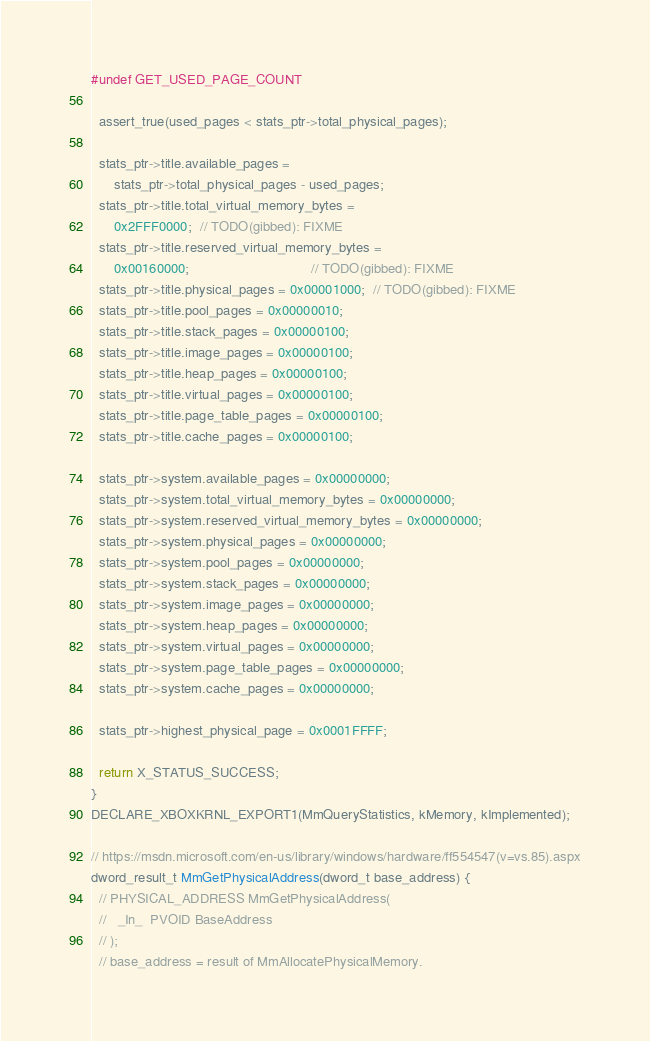Convert code to text. <code><loc_0><loc_0><loc_500><loc_500><_C++_>#undef GET_USED_PAGE_COUNT

  assert_true(used_pages < stats_ptr->total_physical_pages);

  stats_ptr->title.available_pages =
      stats_ptr->total_physical_pages - used_pages;
  stats_ptr->title.total_virtual_memory_bytes =
      0x2FFF0000;  // TODO(gibbed): FIXME
  stats_ptr->title.reserved_virtual_memory_bytes =
      0x00160000;                                // TODO(gibbed): FIXME
  stats_ptr->title.physical_pages = 0x00001000;  // TODO(gibbed): FIXME
  stats_ptr->title.pool_pages = 0x00000010;
  stats_ptr->title.stack_pages = 0x00000100;
  stats_ptr->title.image_pages = 0x00000100;
  stats_ptr->title.heap_pages = 0x00000100;
  stats_ptr->title.virtual_pages = 0x00000100;
  stats_ptr->title.page_table_pages = 0x00000100;
  stats_ptr->title.cache_pages = 0x00000100;

  stats_ptr->system.available_pages = 0x00000000;
  stats_ptr->system.total_virtual_memory_bytes = 0x00000000;
  stats_ptr->system.reserved_virtual_memory_bytes = 0x00000000;
  stats_ptr->system.physical_pages = 0x00000000;
  stats_ptr->system.pool_pages = 0x00000000;
  stats_ptr->system.stack_pages = 0x00000000;
  stats_ptr->system.image_pages = 0x00000000;
  stats_ptr->system.heap_pages = 0x00000000;
  stats_ptr->system.virtual_pages = 0x00000000;
  stats_ptr->system.page_table_pages = 0x00000000;
  stats_ptr->system.cache_pages = 0x00000000;

  stats_ptr->highest_physical_page = 0x0001FFFF;

  return X_STATUS_SUCCESS;
}
DECLARE_XBOXKRNL_EXPORT1(MmQueryStatistics, kMemory, kImplemented);

// https://msdn.microsoft.com/en-us/library/windows/hardware/ff554547(v=vs.85).aspx
dword_result_t MmGetPhysicalAddress(dword_t base_address) {
  // PHYSICAL_ADDRESS MmGetPhysicalAddress(
  //   _In_  PVOID BaseAddress
  // );
  // base_address = result of MmAllocatePhysicalMemory.</code> 